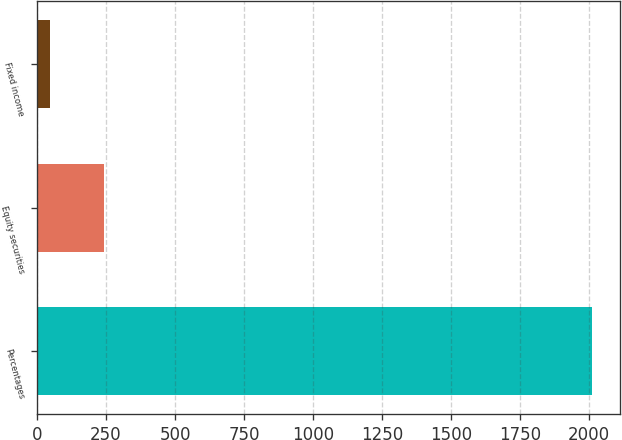Convert chart. <chart><loc_0><loc_0><loc_500><loc_500><bar_chart><fcel>Percentages<fcel>Equity securities<fcel>Fixed income<nl><fcel>2012<fcel>241.7<fcel>45<nl></chart> 